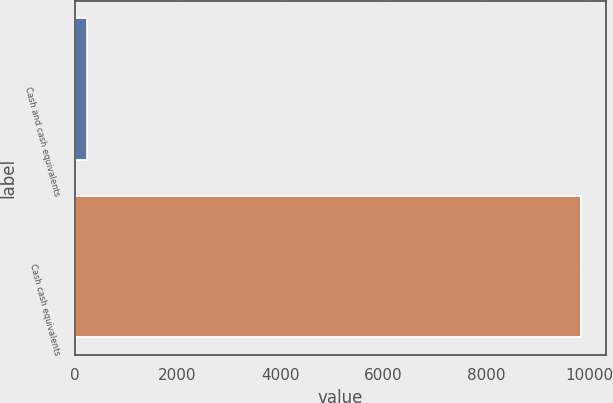Convert chart. <chart><loc_0><loc_0><loc_500><loc_500><bar_chart><fcel>Cash and cash equivalents<fcel>Cash cash equivalents<nl><fcel>241<fcel>9833.7<nl></chart> 